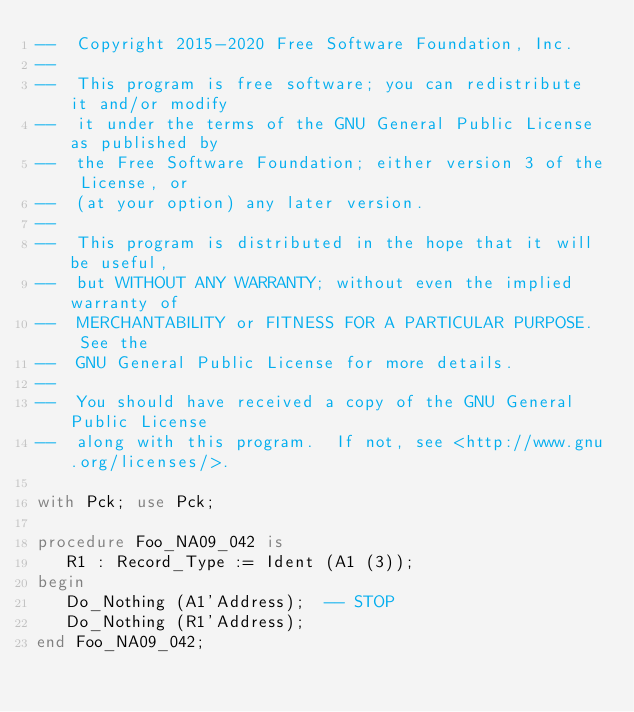Convert code to text. <code><loc_0><loc_0><loc_500><loc_500><_Ada_>--  Copyright 2015-2020 Free Software Foundation, Inc.
--
--  This program is free software; you can redistribute it and/or modify
--  it under the terms of the GNU General Public License as published by
--  the Free Software Foundation; either version 3 of the License, or
--  (at your option) any later version.
--
--  This program is distributed in the hope that it will be useful,
--  but WITHOUT ANY WARRANTY; without even the implied warranty of
--  MERCHANTABILITY or FITNESS FOR A PARTICULAR PURPOSE.  See the
--  GNU General Public License for more details.
--
--  You should have received a copy of the GNU General Public License
--  along with this program.  If not, see <http://www.gnu.org/licenses/>.

with Pck; use Pck;

procedure Foo_NA09_042 is
   R1 : Record_Type := Ident (A1 (3));
begin
   Do_Nothing (A1'Address);  -- STOP
   Do_Nothing (R1'Address);
end Foo_NA09_042;
</code> 